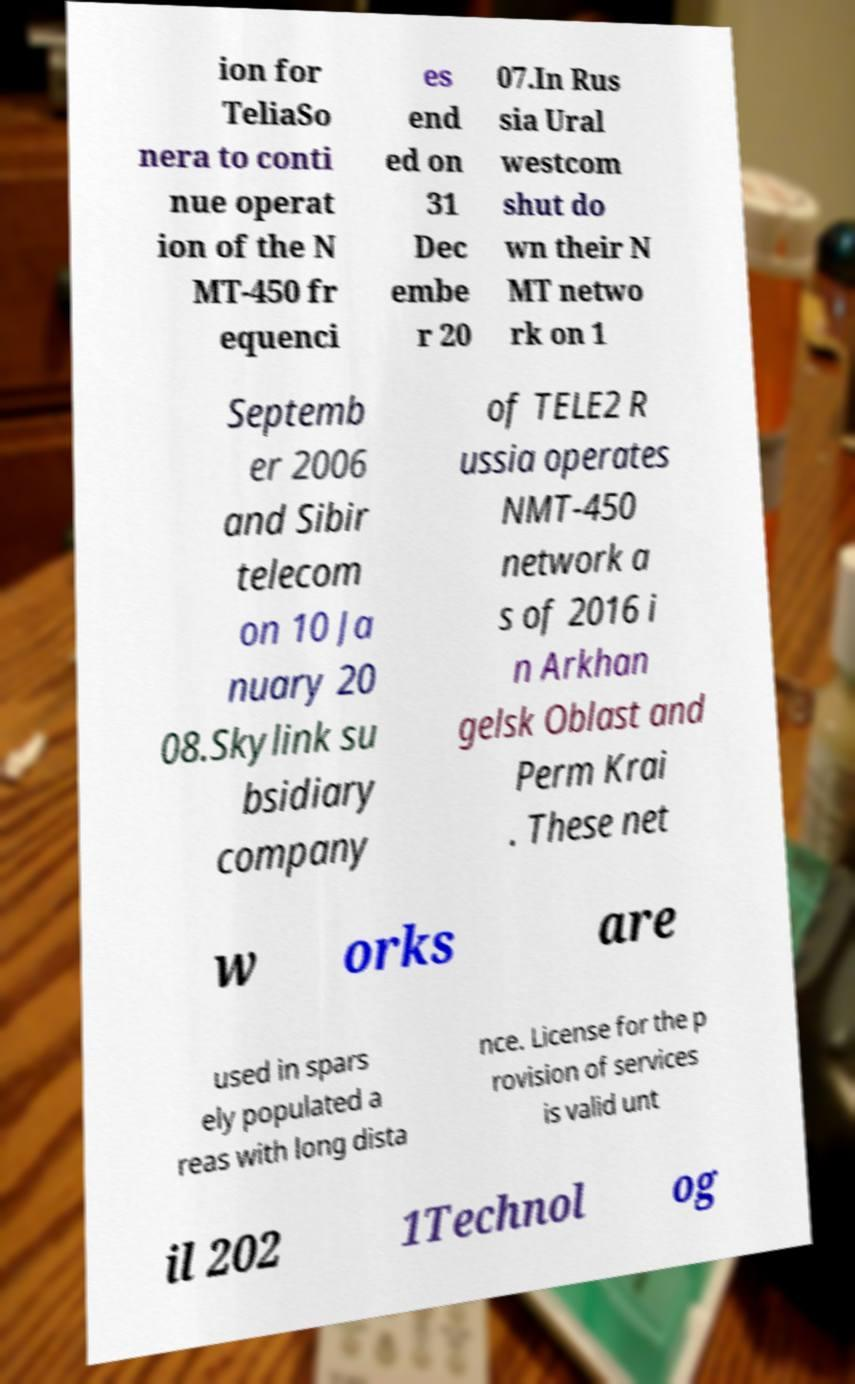I need the written content from this picture converted into text. Can you do that? ion for TeliaSo nera to conti nue operat ion of the N MT-450 fr equenci es end ed on 31 Dec embe r 20 07.In Rus sia Ural westcom shut do wn their N MT netwo rk on 1 Septemb er 2006 and Sibir telecom on 10 Ja nuary 20 08.Skylink su bsidiary company of TELE2 R ussia operates NMT-450 network a s of 2016 i n Arkhan gelsk Oblast and Perm Krai . These net w orks are used in spars ely populated a reas with long dista nce. License for the p rovision of services is valid unt il 202 1Technol og 